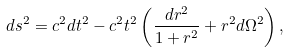Convert formula to latex. <formula><loc_0><loc_0><loc_500><loc_500>d s ^ { 2 } = c ^ { 2 } d t ^ { 2 } - c ^ { 2 } t ^ { 2 } \left ( \frac { d r ^ { 2 } } { 1 + r ^ { 2 } } + r ^ { 2 } d \Omega ^ { 2 } \right ) ,</formula> 